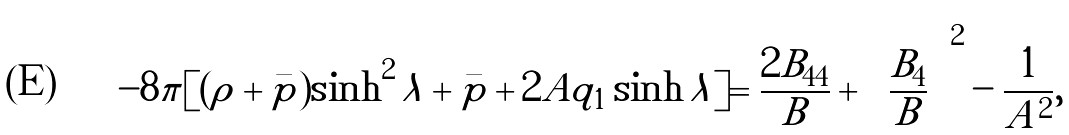<formula> <loc_0><loc_0><loc_500><loc_500>- 8 \pi [ ( \rho + \bar { p } ) \sinh ^ { 2 } \lambda + \bar { p } + 2 A q _ { 1 } \sinh \lambda ] = \frac { 2 B _ { 4 4 } } { B } + \left ( \frac { B _ { 4 } } { B } \right ) ^ { 2 } - \frac { 1 } { A ^ { 2 } } ,</formula> 